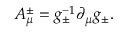<formula> <loc_0><loc_0><loc_500><loc_500>A _ { \mu } ^ { \pm } = g _ { \pm } ^ { - 1 } \partial _ { \mu } g _ { \pm } .</formula> 